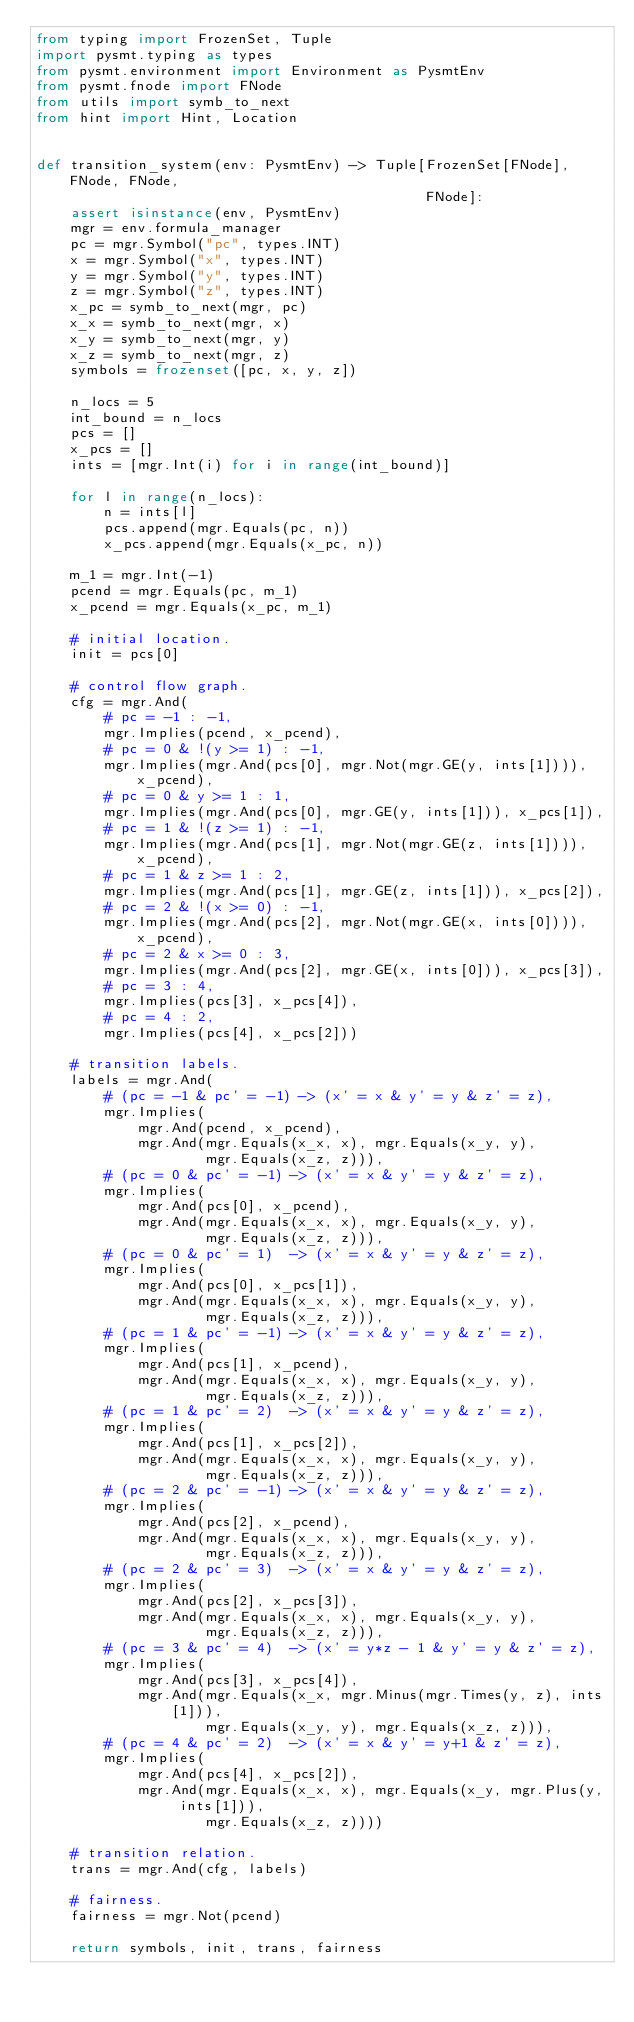Convert code to text. <code><loc_0><loc_0><loc_500><loc_500><_Python_>from typing import FrozenSet, Tuple
import pysmt.typing as types
from pysmt.environment import Environment as PysmtEnv
from pysmt.fnode import FNode
from utils import symb_to_next
from hint import Hint, Location


def transition_system(env: PysmtEnv) -> Tuple[FrozenSet[FNode], FNode, FNode,
                                              FNode]:
    assert isinstance(env, PysmtEnv)
    mgr = env.formula_manager
    pc = mgr.Symbol("pc", types.INT)
    x = mgr.Symbol("x", types.INT)
    y = mgr.Symbol("y", types.INT)
    z = mgr.Symbol("z", types.INT)
    x_pc = symb_to_next(mgr, pc)
    x_x = symb_to_next(mgr, x)
    x_y = symb_to_next(mgr, y)
    x_z = symb_to_next(mgr, z)
    symbols = frozenset([pc, x, y, z])

    n_locs = 5
    int_bound = n_locs
    pcs = []
    x_pcs = []
    ints = [mgr.Int(i) for i in range(int_bound)]

    for l in range(n_locs):
        n = ints[l]
        pcs.append(mgr.Equals(pc, n))
        x_pcs.append(mgr.Equals(x_pc, n))

    m_1 = mgr.Int(-1)
    pcend = mgr.Equals(pc, m_1)
    x_pcend = mgr.Equals(x_pc, m_1)

    # initial location.
    init = pcs[0]

    # control flow graph.
    cfg = mgr.And(
        # pc = -1 : -1,
        mgr.Implies(pcend, x_pcend),
        # pc = 0 & !(y >= 1) : -1,
        mgr.Implies(mgr.And(pcs[0], mgr.Not(mgr.GE(y, ints[1]))), x_pcend),
        # pc = 0 & y >= 1 : 1,
        mgr.Implies(mgr.And(pcs[0], mgr.GE(y, ints[1])), x_pcs[1]),
        # pc = 1 & !(z >= 1) : -1,
        mgr.Implies(mgr.And(pcs[1], mgr.Not(mgr.GE(z, ints[1]))), x_pcend),
        # pc = 1 & z >= 1 : 2,
        mgr.Implies(mgr.And(pcs[1], mgr.GE(z, ints[1])), x_pcs[2]),
        # pc = 2 & !(x >= 0) : -1,
        mgr.Implies(mgr.And(pcs[2], mgr.Not(mgr.GE(x, ints[0]))), x_pcend),
        # pc = 2 & x >= 0 : 3,
        mgr.Implies(mgr.And(pcs[2], mgr.GE(x, ints[0])), x_pcs[3]),
        # pc = 3 : 4,
        mgr.Implies(pcs[3], x_pcs[4]),
        # pc = 4 : 2,
        mgr.Implies(pcs[4], x_pcs[2]))

    # transition labels.
    labels = mgr.And(
        # (pc = -1 & pc' = -1) -> (x' = x & y' = y & z' = z),
        mgr.Implies(
            mgr.And(pcend, x_pcend),
            mgr.And(mgr.Equals(x_x, x), mgr.Equals(x_y, y),
                    mgr.Equals(x_z, z))),
        # (pc = 0 & pc' = -1) -> (x' = x & y' = y & z' = z),
        mgr.Implies(
            mgr.And(pcs[0], x_pcend),
            mgr.And(mgr.Equals(x_x, x), mgr.Equals(x_y, y),
                    mgr.Equals(x_z, z))),
        # (pc = 0 & pc' = 1)  -> (x' = x & y' = y & z' = z),
        mgr.Implies(
            mgr.And(pcs[0], x_pcs[1]),
            mgr.And(mgr.Equals(x_x, x), mgr.Equals(x_y, y),
                    mgr.Equals(x_z, z))),
        # (pc = 1 & pc' = -1) -> (x' = x & y' = y & z' = z),
        mgr.Implies(
            mgr.And(pcs[1], x_pcend),
            mgr.And(mgr.Equals(x_x, x), mgr.Equals(x_y, y),
                    mgr.Equals(x_z, z))),
        # (pc = 1 & pc' = 2)  -> (x' = x & y' = y & z' = z),
        mgr.Implies(
            mgr.And(pcs[1], x_pcs[2]),
            mgr.And(mgr.Equals(x_x, x), mgr.Equals(x_y, y),
                    mgr.Equals(x_z, z))),
        # (pc = 2 & pc' = -1) -> (x' = x & y' = y & z' = z),
        mgr.Implies(
            mgr.And(pcs[2], x_pcend),
            mgr.And(mgr.Equals(x_x, x), mgr.Equals(x_y, y),
                    mgr.Equals(x_z, z))),
        # (pc = 2 & pc' = 3)  -> (x' = x & y' = y & z' = z),
        mgr.Implies(
            mgr.And(pcs[2], x_pcs[3]),
            mgr.And(mgr.Equals(x_x, x), mgr.Equals(x_y, y),
                    mgr.Equals(x_z, z))),
        # (pc = 3 & pc' = 4)  -> (x' = y*z - 1 & y' = y & z' = z),
        mgr.Implies(
            mgr.And(pcs[3], x_pcs[4]),
            mgr.And(mgr.Equals(x_x, mgr.Minus(mgr.Times(y, z), ints[1])),
                    mgr.Equals(x_y, y), mgr.Equals(x_z, z))),
        # (pc = 4 & pc' = 2)  -> (x' = x & y' = y+1 & z' = z),
        mgr.Implies(
            mgr.And(pcs[4], x_pcs[2]),
            mgr.And(mgr.Equals(x_x, x), mgr.Equals(x_y, mgr.Plus(y, ints[1])),
                    mgr.Equals(x_z, z))))

    # transition relation.
    trans = mgr.And(cfg, labels)

    # fairness.
    fairness = mgr.Not(pcend)

    return symbols, init, trans, fairness

</code> 